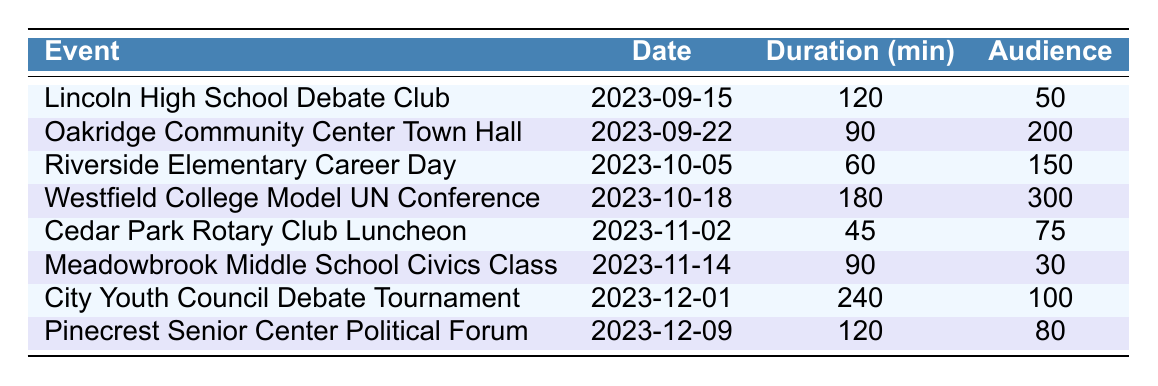What is the event scheduled on November 2, 2023? By locating the row corresponding to the date "2023-11-02" in the table, I can see that the event is "Cedar Park Rotary Club Luncheon".
Answer: Cedar Park Rotary Club Luncheon How many events are scheduled in December 2023? Looking at the table, there are two entries for December: "City Youth Council Debate Tournament" on December 1 and "Pinecrest Senior Center Political Forum" on December 9. Thus, there are 2 events in total.
Answer: 2 What is the total audience size for the events in October? The events in October are "Riverside Elementary Career Day" with 150 audience members and "Westfield College Model UN Conference" with 300 audience members. Adding these together: 150 + 300 = 450.
Answer: 450 Which event has the largest audience size? Comparing the audience sizes listed in the table, "Westfield College Model UN Conference" has the largest audience size of 300.
Answer: 300 What is the average duration of the events in the table? Summing the durations: 120 + 90 + 60 + 180 + 45 + 90 + 240 + 120 = 945 minutes. There are 8 events, so the average duration is 945 / 8 = 118.125 minutes, which rounds to approximately 118 minutes.
Answer: 118 minutes Is there an event scheduled longer than 180 minutes? Checking the duration column, the longest duration listed is 240 minutes for the "City Youth Council Debate Tournament," so yes, there is an event longer than 180 minutes.
Answer: Yes What is the median audience size in the schedule? The audience sizes listed are: 50, 200, 150, 300, 75, 30, 100, and 80. First, I will arrange them in order: 30, 50, 75, 80, 100, 150, 200, 300. The median is the average of the 4th and 5th values (80 and 100), so (80 + 100) / 2 = 90.
Answer: 90 How many events have a duration greater than 90 minutes? Reviewing the durations, the events with durations greater than 90 minutes are "Lincoln High School Debate Club" (120), "Westfield College Model UN Conference" (180), and "City Youth Council Debate Tournament" (240). This totals 3 events.
Answer: 3 What is the total duration of events at Meadowbrook Middle School and Pinecrest Senior Center? From the table, "Meadowbrook Middle School Civics Class" has a duration of 90 minutes, and "Pinecrest Senior Center Political Forum" has a duration of 120 minutes. Adding these gives: 90 + 120 = 210 minutes.
Answer: 210 minutes Which month features the event with the lowest audience size? Examining the audience sizes, "Meadowbrook Middle School Civics Class" on November 14 has the lowest at 30 audience members. November is the month that features this event.
Answer: November What percentages of the total audience sizes are for events held at schools? The audiences at schools are 50 (Lincoln High School) + 150 (Riverside Elementary) + 30 (Meadowbrook Middle) = 230. The total audience sizes are 50 + 200 + 150 + 300 + 75 + 30 + 100 + 80 = 985. The percentage is (230 / 985) * 100 ≈ 23.32%.
Answer: Approximately 23.32% 